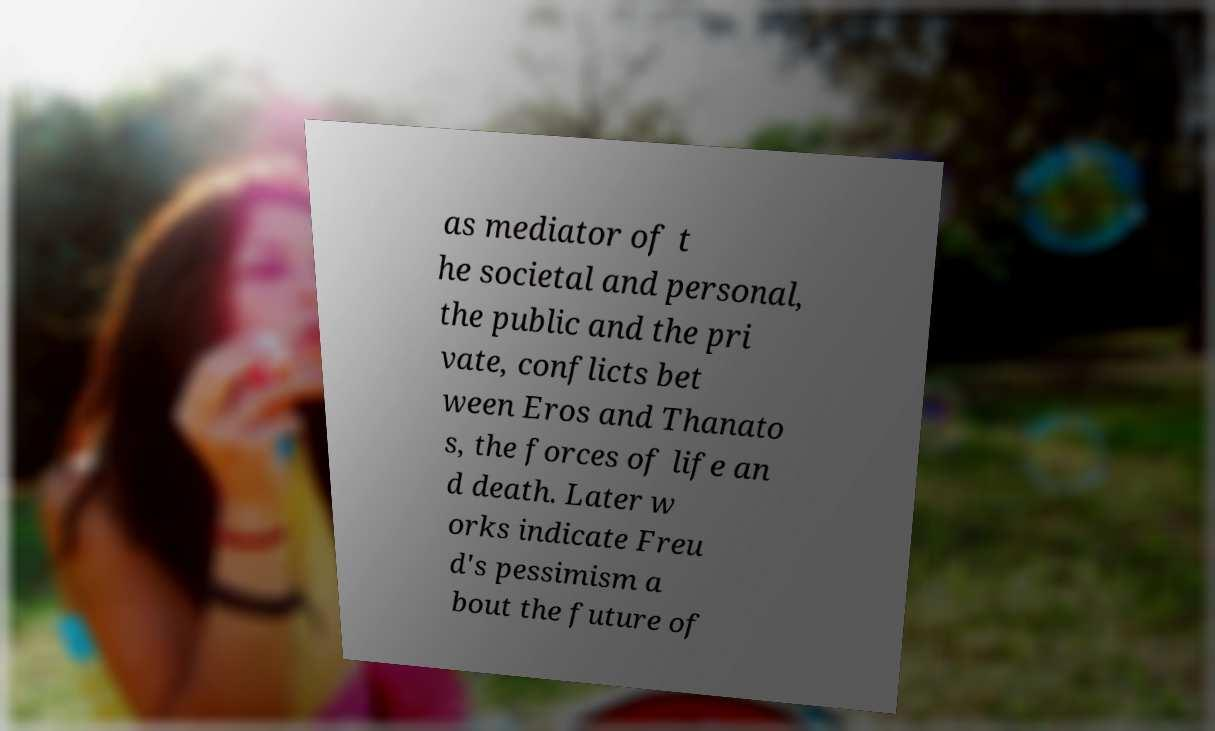There's text embedded in this image that I need extracted. Can you transcribe it verbatim? as mediator of t he societal and personal, the public and the pri vate, conflicts bet ween Eros and Thanato s, the forces of life an d death. Later w orks indicate Freu d's pessimism a bout the future of 